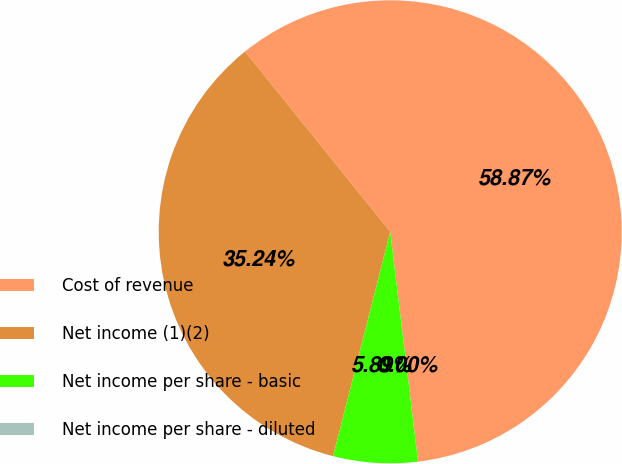<chart> <loc_0><loc_0><loc_500><loc_500><pie_chart><fcel>Cost of revenue<fcel>Net income (1)(2)<fcel>Net income per share - basic<fcel>Net income per share - diluted<nl><fcel>58.88%<fcel>35.24%<fcel>5.89%<fcel>0.0%<nl></chart> 